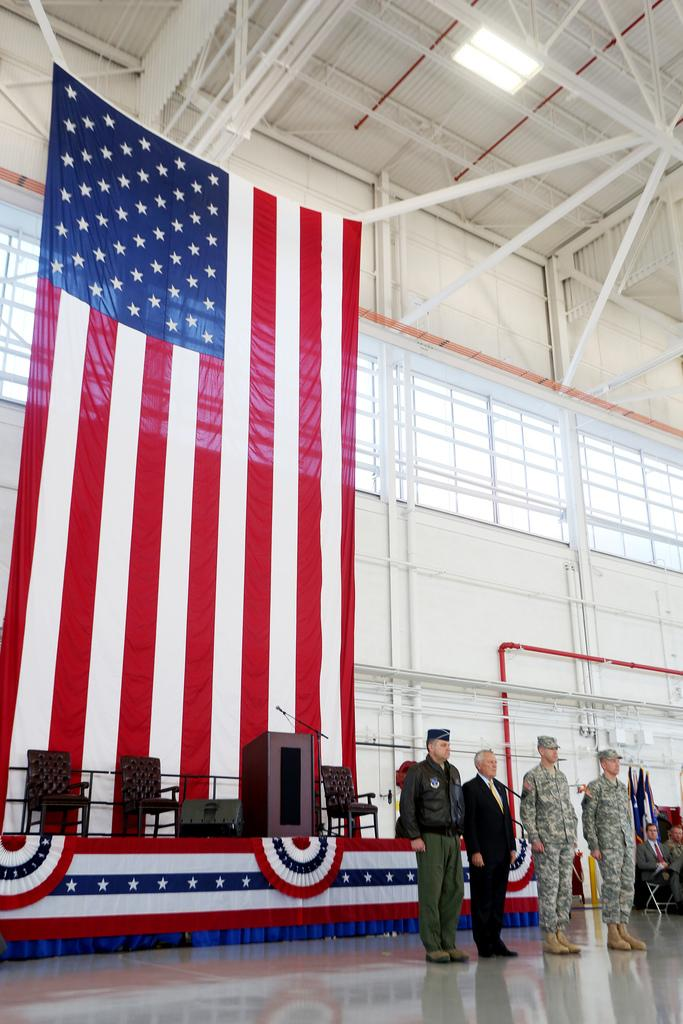What is happening in the image? There is a group of persons standing in the image. Where are the persons located in the image? The group of persons is at the bottom of the image. What can be seen in the background of the image? There is a wall in the background of the image. What is on the left side of the image? There is a flag on the left side of the image. What type of sweater is the person in the middle of the group wearing? There is no information about the apparel of the persons in the image, so we cannot determine if any of them are wearing a sweater. 